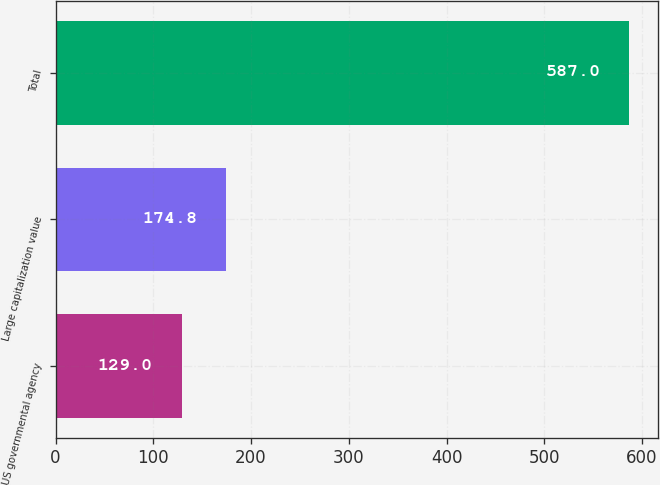Convert chart. <chart><loc_0><loc_0><loc_500><loc_500><bar_chart><fcel>US governmental agency<fcel>Large capitalization value<fcel>Total<nl><fcel>129<fcel>174.8<fcel>587<nl></chart> 